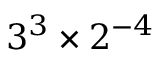Convert formula to latex. <formula><loc_0><loc_0><loc_500><loc_500>3 ^ { 3 } \times 2 ^ { - 4 }</formula> 